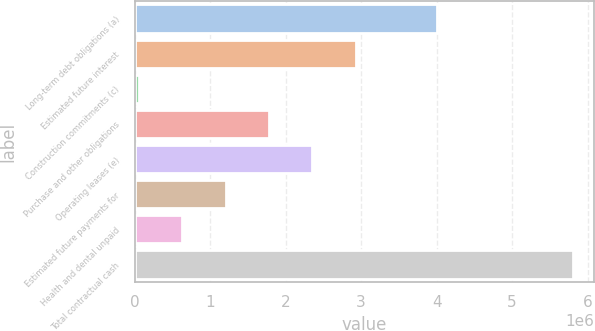<chart> <loc_0><loc_0><loc_500><loc_500><bar_chart><fcel>Long-term debt obligations (a)<fcel>Estimated future interest<fcel>Construction commitments (c)<fcel>Purchase and other obligations<fcel>Operating leases (e)<fcel>Estimated future payments for<fcel>Health and dental unpaid<fcel>Total contractual cash<nl><fcel>3.99864e+06<fcel>2.92771e+06<fcel>54750<fcel>1.77853e+06<fcel>2.35312e+06<fcel>1.20393e+06<fcel>629342<fcel>5.80067e+06<nl></chart> 